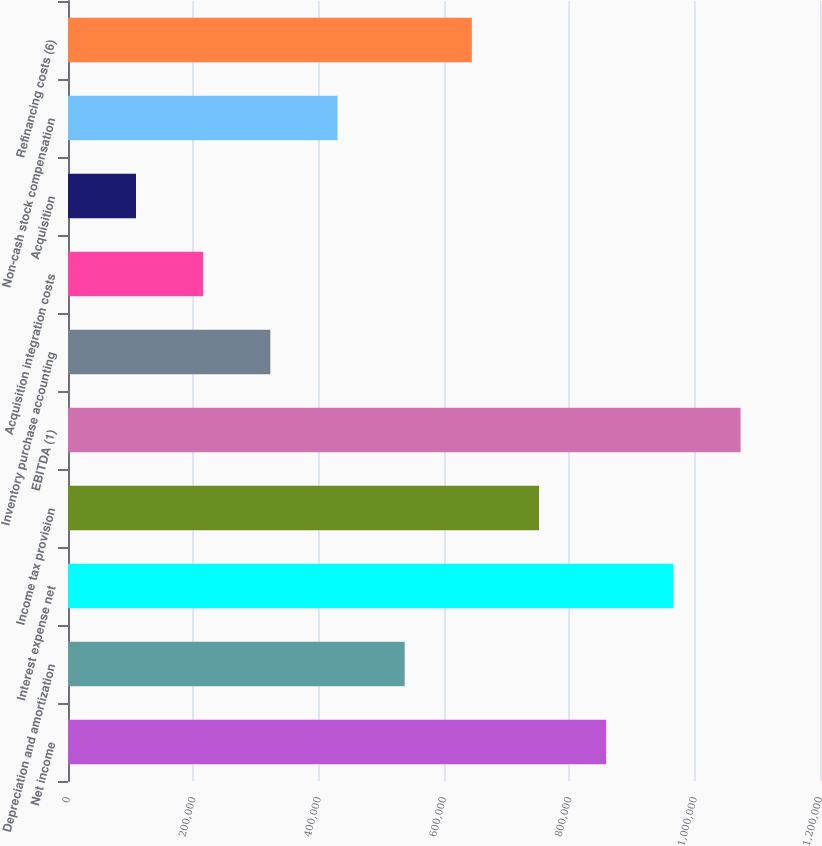Convert chart. <chart><loc_0><loc_0><loc_500><loc_500><bar_chart><fcel>Net income<fcel>Depreciation and amortization<fcel>Interest expense net<fcel>Income tax provision<fcel>EBITDA (1)<fcel>Inventory purchase accounting<fcel>Acquisition integration costs<fcel>Acquisition<fcel>Non-cash stock compensation<fcel>Refinancing costs (6)<nl><fcel>858831<fcel>537266<fcel>966019<fcel>751642<fcel>1.07321e+06<fcel>322890<fcel>215701<fcel>108513<fcel>430078<fcel>644454<nl></chart> 